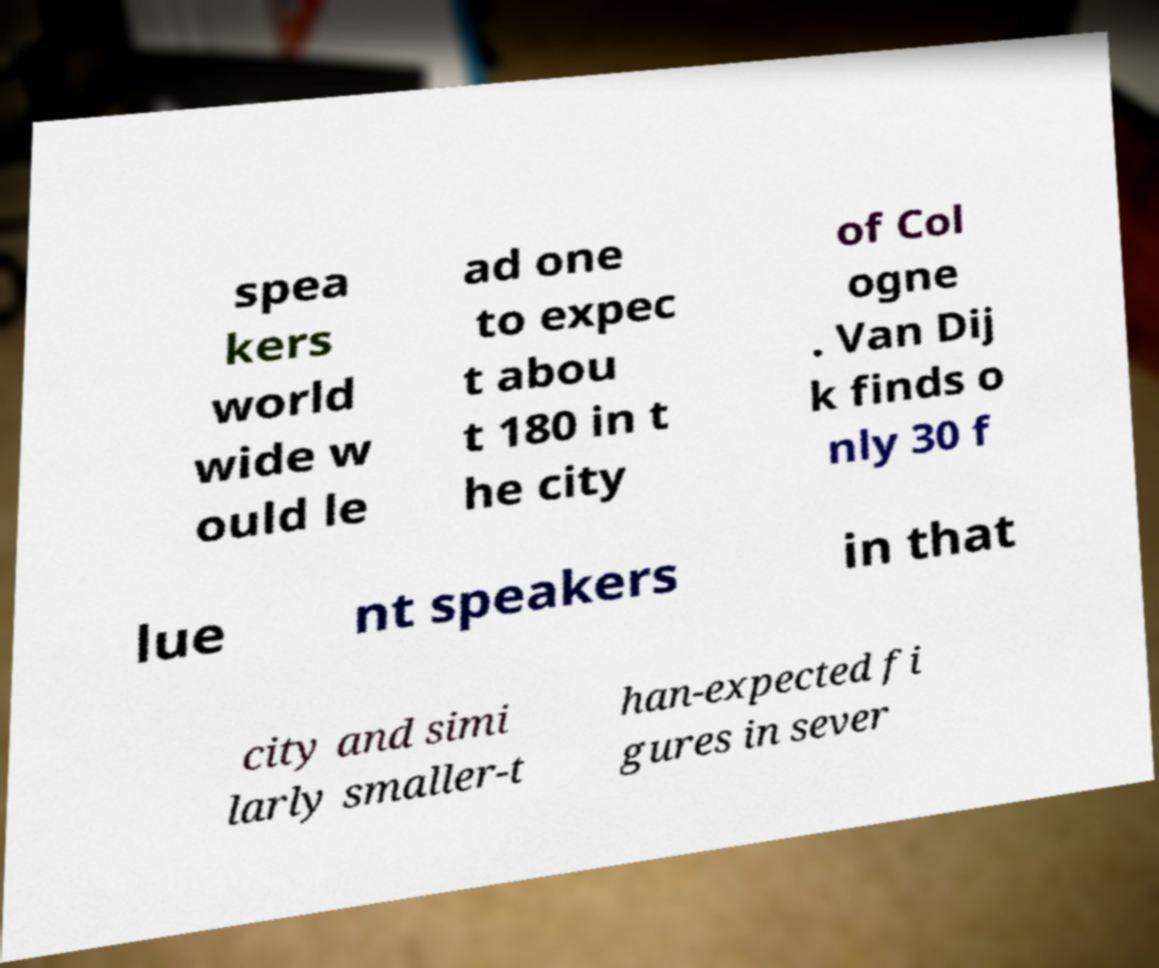Could you extract and type out the text from this image? spea kers world wide w ould le ad one to expec t abou t 180 in t he city of Col ogne . Van Dij k finds o nly 30 f lue nt speakers in that city and simi larly smaller-t han-expected fi gures in sever 